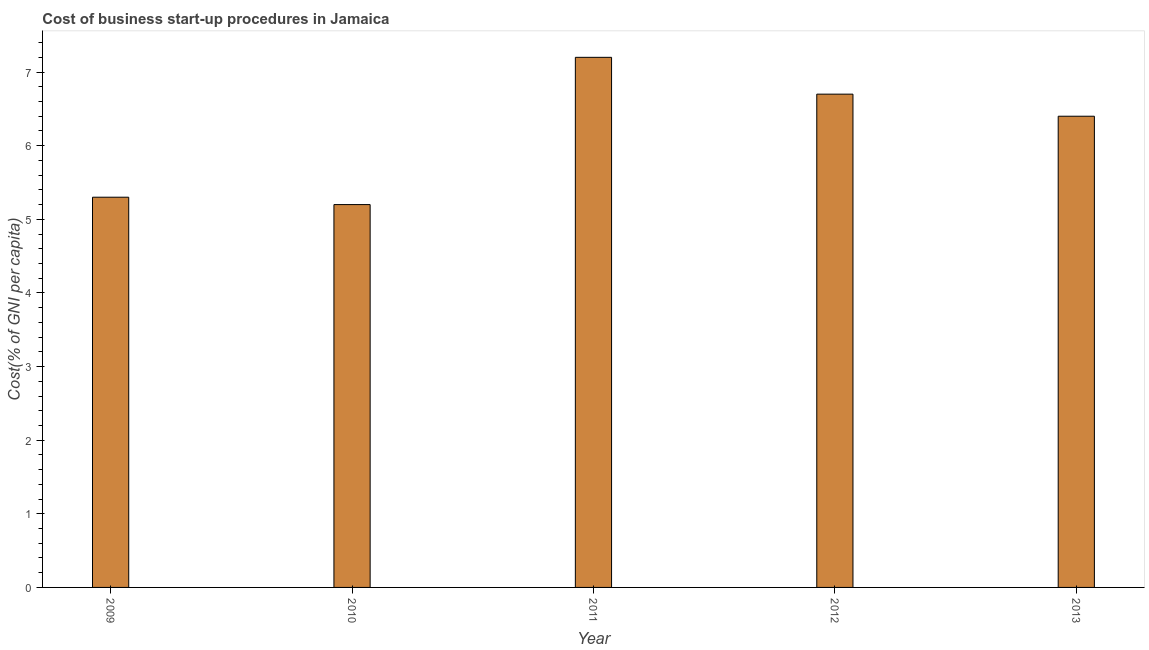Does the graph contain grids?
Make the answer very short. No. What is the title of the graph?
Provide a succinct answer. Cost of business start-up procedures in Jamaica. What is the label or title of the Y-axis?
Your answer should be compact. Cost(% of GNI per capita). Across all years, what is the minimum cost of business startup procedures?
Keep it short and to the point. 5.2. In which year was the cost of business startup procedures maximum?
Offer a terse response. 2011. In which year was the cost of business startup procedures minimum?
Make the answer very short. 2010. What is the sum of the cost of business startup procedures?
Ensure brevity in your answer.  30.8. What is the average cost of business startup procedures per year?
Offer a terse response. 6.16. What is the ratio of the cost of business startup procedures in 2009 to that in 2012?
Your response must be concise. 0.79. Is the difference between the cost of business startup procedures in 2010 and 2012 greater than the difference between any two years?
Ensure brevity in your answer.  No. Is the sum of the cost of business startup procedures in 2011 and 2013 greater than the maximum cost of business startup procedures across all years?
Your response must be concise. Yes. What is the difference between the highest and the lowest cost of business startup procedures?
Your answer should be very brief. 2. In how many years, is the cost of business startup procedures greater than the average cost of business startup procedures taken over all years?
Provide a short and direct response. 3. Are all the bars in the graph horizontal?
Ensure brevity in your answer.  No. How many years are there in the graph?
Your response must be concise. 5. What is the difference between two consecutive major ticks on the Y-axis?
Your answer should be very brief. 1. Are the values on the major ticks of Y-axis written in scientific E-notation?
Your answer should be compact. No. What is the Cost(% of GNI per capita) in 2010?
Make the answer very short. 5.2. What is the Cost(% of GNI per capita) of 2013?
Your answer should be very brief. 6.4. What is the difference between the Cost(% of GNI per capita) in 2009 and 2010?
Make the answer very short. 0.1. What is the difference between the Cost(% of GNI per capita) in 2009 and 2011?
Your answer should be very brief. -1.9. What is the difference between the Cost(% of GNI per capita) in 2009 and 2012?
Your response must be concise. -1.4. What is the difference between the Cost(% of GNI per capita) in 2011 and 2012?
Provide a short and direct response. 0.5. What is the ratio of the Cost(% of GNI per capita) in 2009 to that in 2010?
Ensure brevity in your answer.  1.02. What is the ratio of the Cost(% of GNI per capita) in 2009 to that in 2011?
Keep it short and to the point. 0.74. What is the ratio of the Cost(% of GNI per capita) in 2009 to that in 2012?
Give a very brief answer. 0.79. What is the ratio of the Cost(% of GNI per capita) in 2009 to that in 2013?
Provide a short and direct response. 0.83. What is the ratio of the Cost(% of GNI per capita) in 2010 to that in 2011?
Keep it short and to the point. 0.72. What is the ratio of the Cost(% of GNI per capita) in 2010 to that in 2012?
Your answer should be compact. 0.78. What is the ratio of the Cost(% of GNI per capita) in 2010 to that in 2013?
Provide a short and direct response. 0.81. What is the ratio of the Cost(% of GNI per capita) in 2011 to that in 2012?
Keep it short and to the point. 1.07. What is the ratio of the Cost(% of GNI per capita) in 2011 to that in 2013?
Keep it short and to the point. 1.12. What is the ratio of the Cost(% of GNI per capita) in 2012 to that in 2013?
Offer a very short reply. 1.05. 